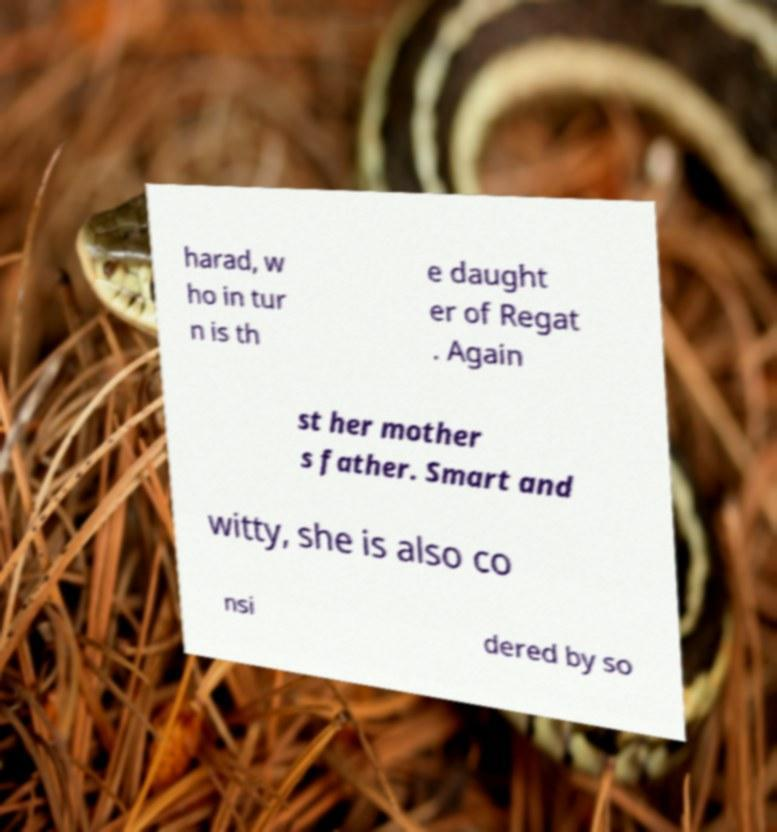Please identify and transcribe the text found in this image. harad, w ho in tur n is th e daught er of Regat . Again st her mother s father. Smart and witty, she is also co nsi dered by so 